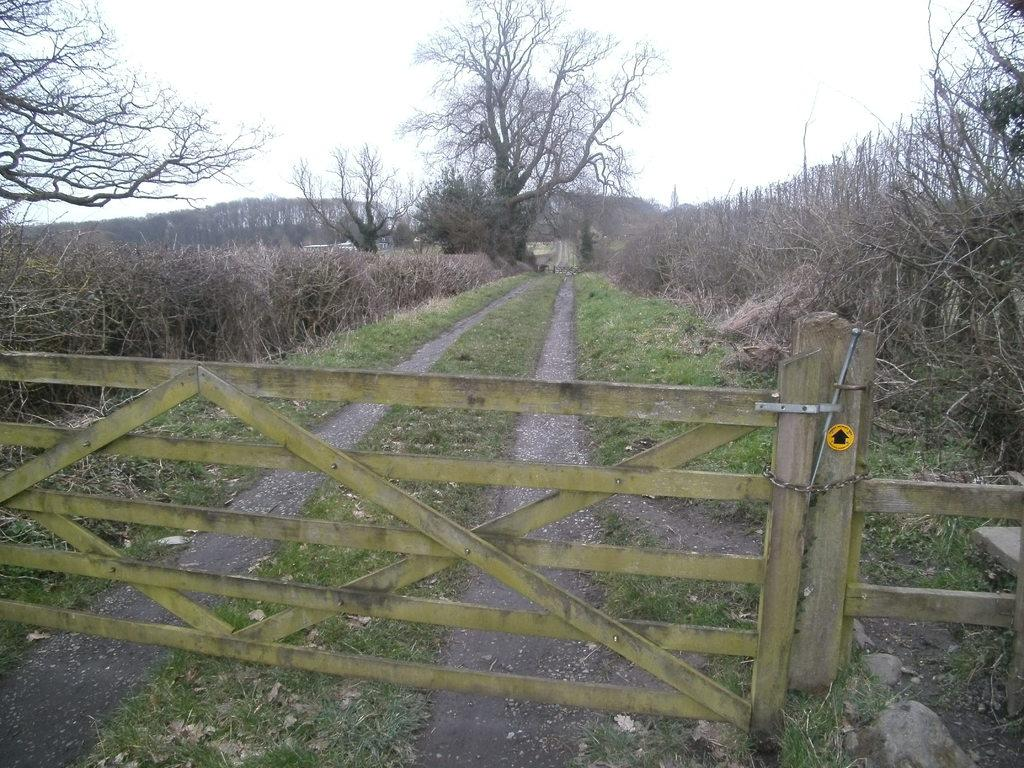What type of vegetation can be seen in the image? There are trees, plants, and grass in the image. What type of barrier is present in the image? There is a wooden fence in the image. What can be seen in the background of the image? The sky is visible in the background of the image. Can you tell me how many times the picture was run before being framed? There is no picture mentioned in the image, and therefore no information about it being run or framed. 